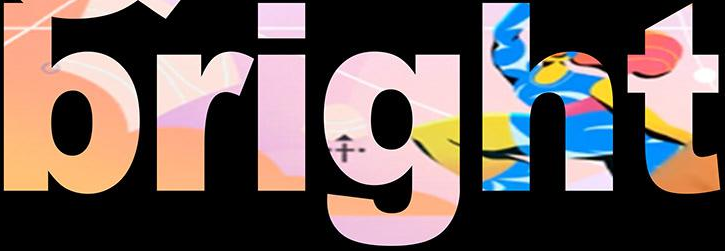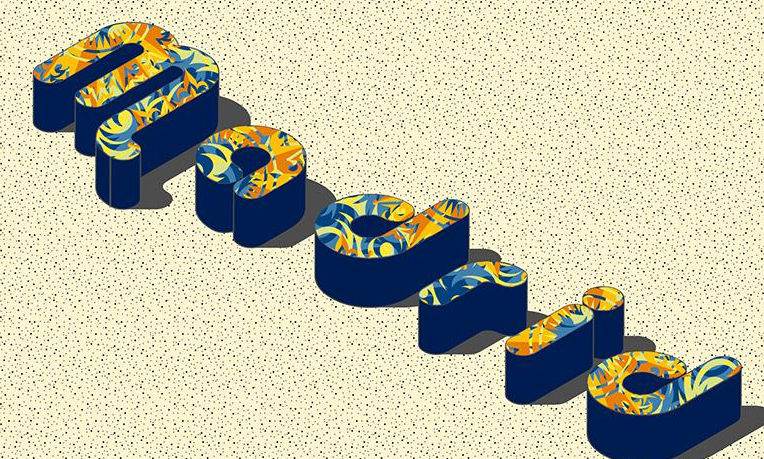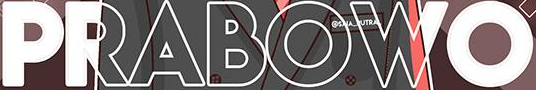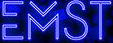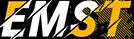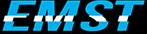Identify the words shown in these images in order, separated by a semicolon. bright; Madrid; PRABOWO; EMST; EMST; EMST 